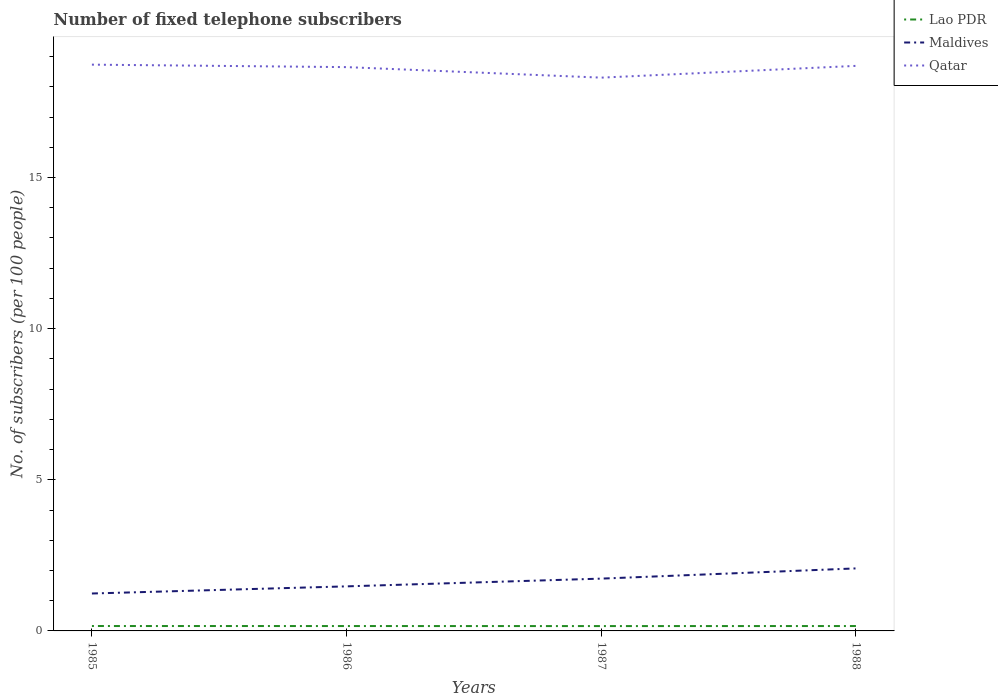How many different coloured lines are there?
Offer a terse response. 3. Does the line corresponding to Maldives intersect with the line corresponding to Lao PDR?
Make the answer very short. No. Is the number of lines equal to the number of legend labels?
Provide a succinct answer. Yes. Across all years, what is the maximum number of fixed telephone subscribers in Lao PDR?
Your response must be concise. 0.16. What is the total number of fixed telephone subscribers in Lao PDR in the graph?
Offer a very short reply. 0. What is the difference between the highest and the second highest number of fixed telephone subscribers in Qatar?
Offer a very short reply. 0.43. What is the difference between the highest and the lowest number of fixed telephone subscribers in Lao PDR?
Make the answer very short. 3. Are the values on the major ticks of Y-axis written in scientific E-notation?
Ensure brevity in your answer.  No. Does the graph contain grids?
Your response must be concise. No. Where does the legend appear in the graph?
Your response must be concise. Top right. What is the title of the graph?
Your response must be concise. Number of fixed telephone subscribers. What is the label or title of the Y-axis?
Your answer should be compact. No. of subscribers (per 100 people). What is the No. of subscribers (per 100 people) of Lao PDR in 1985?
Keep it short and to the point. 0.16. What is the No. of subscribers (per 100 people) of Maldives in 1985?
Your response must be concise. 1.24. What is the No. of subscribers (per 100 people) of Qatar in 1985?
Offer a terse response. 18.73. What is the No. of subscribers (per 100 people) in Lao PDR in 1986?
Provide a short and direct response. 0.16. What is the No. of subscribers (per 100 people) in Maldives in 1986?
Your answer should be compact. 1.47. What is the No. of subscribers (per 100 people) in Qatar in 1986?
Offer a terse response. 18.65. What is the No. of subscribers (per 100 people) of Lao PDR in 1987?
Provide a short and direct response. 0.16. What is the No. of subscribers (per 100 people) of Maldives in 1987?
Provide a short and direct response. 1.73. What is the No. of subscribers (per 100 people) of Qatar in 1987?
Your response must be concise. 18.3. What is the No. of subscribers (per 100 people) of Lao PDR in 1988?
Your answer should be very brief. 0.16. What is the No. of subscribers (per 100 people) of Maldives in 1988?
Provide a short and direct response. 2.07. What is the No. of subscribers (per 100 people) of Qatar in 1988?
Give a very brief answer. 18.69. Across all years, what is the maximum No. of subscribers (per 100 people) in Lao PDR?
Offer a very short reply. 0.16. Across all years, what is the maximum No. of subscribers (per 100 people) of Maldives?
Provide a succinct answer. 2.07. Across all years, what is the maximum No. of subscribers (per 100 people) of Qatar?
Offer a very short reply. 18.73. Across all years, what is the minimum No. of subscribers (per 100 people) in Lao PDR?
Offer a very short reply. 0.16. Across all years, what is the minimum No. of subscribers (per 100 people) of Maldives?
Give a very brief answer. 1.24. Across all years, what is the minimum No. of subscribers (per 100 people) of Qatar?
Provide a succinct answer. 18.3. What is the total No. of subscribers (per 100 people) in Lao PDR in the graph?
Offer a very short reply. 0.65. What is the total No. of subscribers (per 100 people) of Maldives in the graph?
Your answer should be very brief. 6.51. What is the total No. of subscribers (per 100 people) in Qatar in the graph?
Your answer should be compact. 74.38. What is the difference between the No. of subscribers (per 100 people) in Lao PDR in 1985 and that in 1986?
Provide a succinct answer. 0. What is the difference between the No. of subscribers (per 100 people) in Maldives in 1985 and that in 1986?
Your response must be concise. -0.24. What is the difference between the No. of subscribers (per 100 people) of Qatar in 1985 and that in 1986?
Offer a very short reply. 0.08. What is the difference between the No. of subscribers (per 100 people) in Lao PDR in 1985 and that in 1987?
Give a very brief answer. 0. What is the difference between the No. of subscribers (per 100 people) of Maldives in 1985 and that in 1987?
Provide a short and direct response. -0.49. What is the difference between the No. of subscribers (per 100 people) of Qatar in 1985 and that in 1987?
Ensure brevity in your answer.  0.43. What is the difference between the No. of subscribers (per 100 people) of Lao PDR in 1985 and that in 1988?
Your answer should be compact. 0. What is the difference between the No. of subscribers (per 100 people) of Maldives in 1985 and that in 1988?
Your response must be concise. -0.83. What is the difference between the No. of subscribers (per 100 people) of Qatar in 1985 and that in 1988?
Give a very brief answer. 0.04. What is the difference between the No. of subscribers (per 100 people) in Lao PDR in 1986 and that in 1987?
Your response must be concise. 0. What is the difference between the No. of subscribers (per 100 people) in Maldives in 1986 and that in 1987?
Give a very brief answer. -0.26. What is the difference between the No. of subscribers (per 100 people) of Qatar in 1986 and that in 1987?
Make the answer very short. 0.35. What is the difference between the No. of subscribers (per 100 people) of Lao PDR in 1986 and that in 1988?
Give a very brief answer. -0. What is the difference between the No. of subscribers (per 100 people) of Maldives in 1986 and that in 1988?
Provide a short and direct response. -0.59. What is the difference between the No. of subscribers (per 100 people) in Qatar in 1986 and that in 1988?
Your answer should be very brief. -0.04. What is the difference between the No. of subscribers (per 100 people) in Lao PDR in 1987 and that in 1988?
Provide a succinct answer. -0. What is the difference between the No. of subscribers (per 100 people) of Maldives in 1987 and that in 1988?
Your response must be concise. -0.34. What is the difference between the No. of subscribers (per 100 people) of Qatar in 1987 and that in 1988?
Your response must be concise. -0.39. What is the difference between the No. of subscribers (per 100 people) of Lao PDR in 1985 and the No. of subscribers (per 100 people) of Maldives in 1986?
Keep it short and to the point. -1.31. What is the difference between the No. of subscribers (per 100 people) of Lao PDR in 1985 and the No. of subscribers (per 100 people) of Qatar in 1986?
Provide a succinct answer. -18.49. What is the difference between the No. of subscribers (per 100 people) in Maldives in 1985 and the No. of subscribers (per 100 people) in Qatar in 1986?
Provide a short and direct response. -17.41. What is the difference between the No. of subscribers (per 100 people) of Lao PDR in 1985 and the No. of subscribers (per 100 people) of Maldives in 1987?
Provide a short and direct response. -1.57. What is the difference between the No. of subscribers (per 100 people) in Lao PDR in 1985 and the No. of subscribers (per 100 people) in Qatar in 1987?
Give a very brief answer. -18.14. What is the difference between the No. of subscribers (per 100 people) of Maldives in 1985 and the No. of subscribers (per 100 people) of Qatar in 1987?
Offer a very short reply. -17.06. What is the difference between the No. of subscribers (per 100 people) of Lao PDR in 1985 and the No. of subscribers (per 100 people) of Maldives in 1988?
Offer a very short reply. -1.91. What is the difference between the No. of subscribers (per 100 people) in Lao PDR in 1985 and the No. of subscribers (per 100 people) in Qatar in 1988?
Your response must be concise. -18.53. What is the difference between the No. of subscribers (per 100 people) of Maldives in 1985 and the No. of subscribers (per 100 people) of Qatar in 1988?
Provide a short and direct response. -17.45. What is the difference between the No. of subscribers (per 100 people) of Lao PDR in 1986 and the No. of subscribers (per 100 people) of Maldives in 1987?
Keep it short and to the point. -1.57. What is the difference between the No. of subscribers (per 100 people) in Lao PDR in 1986 and the No. of subscribers (per 100 people) in Qatar in 1987?
Offer a terse response. -18.14. What is the difference between the No. of subscribers (per 100 people) of Maldives in 1986 and the No. of subscribers (per 100 people) of Qatar in 1987?
Your response must be concise. -16.83. What is the difference between the No. of subscribers (per 100 people) of Lao PDR in 1986 and the No. of subscribers (per 100 people) of Maldives in 1988?
Your answer should be compact. -1.91. What is the difference between the No. of subscribers (per 100 people) of Lao PDR in 1986 and the No. of subscribers (per 100 people) of Qatar in 1988?
Provide a succinct answer. -18.53. What is the difference between the No. of subscribers (per 100 people) in Maldives in 1986 and the No. of subscribers (per 100 people) in Qatar in 1988?
Your response must be concise. -17.22. What is the difference between the No. of subscribers (per 100 people) of Lao PDR in 1987 and the No. of subscribers (per 100 people) of Maldives in 1988?
Provide a short and direct response. -1.91. What is the difference between the No. of subscribers (per 100 people) in Lao PDR in 1987 and the No. of subscribers (per 100 people) in Qatar in 1988?
Give a very brief answer. -18.53. What is the difference between the No. of subscribers (per 100 people) in Maldives in 1987 and the No. of subscribers (per 100 people) in Qatar in 1988?
Provide a succinct answer. -16.96. What is the average No. of subscribers (per 100 people) of Lao PDR per year?
Your response must be concise. 0.16. What is the average No. of subscribers (per 100 people) in Maldives per year?
Your answer should be very brief. 1.63. What is the average No. of subscribers (per 100 people) in Qatar per year?
Provide a succinct answer. 18.59. In the year 1985, what is the difference between the No. of subscribers (per 100 people) of Lao PDR and No. of subscribers (per 100 people) of Maldives?
Make the answer very short. -1.08. In the year 1985, what is the difference between the No. of subscribers (per 100 people) of Lao PDR and No. of subscribers (per 100 people) of Qatar?
Your response must be concise. -18.57. In the year 1985, what is the difference between the No. of subscribers (per 100 people) of Maldives and No. of subscribers (per 100 people) of Qatar?
Your answer should be very brief. -17.49. In the year 1986, what is the difference between the No. of subscribers (per 100 people) in Lao PDR and No. of subscribers (per 100 people) in Maldives?
Provide a short and direct response. -1.31. In the year 1986, what is the difference between the No. of subscribers (per 100 people) of Lao PDR and No. of subscribers (per 100 people) of Qatar?
Provide a short and direct response. -18.49. In the year 1986, what is the difference between the No. of subscribers (per 100 people) in Maldives and No. of subscribers (per 100 people) in Qatar?
Make the answer very short. -17.18. In the year 1987, what is the difference between the No. of subscribers (per 100 people) in Lao PDR and No. of subscribers (per 100 people) in Maldives?
Keep it short and to the point. -1.57. In the year 1987, what is the difference between the No. of subscribers (per 100 people) of Lao PDR and No. of subscribers (per 100 people) of Qatar?
Offer a very short reply. -18.14. In the year 1987, what is the difference between the No. of subscribers (per 100 people) in Maldives and No. of subscribers (per 100 people) in Qatar?
Provide a short and direct response. -16.57. In the year 1988, what is the difference between the No. of subscribers (per 100 people) in Lao PDR and No. of subscribers (per 100 people) in Maldives?
Your response must be concise. -1.91. In the year 1988, what is the difference between the No. of subscribers (per 100 people) of Lao PDR and No. of subscribers (per 100 people) of Qatar?
Ensure brevity in your answer.  -18.53. In the year 1988, what is the difference between the No. of subscribers (per 100 people) of Maldives and No. of subscribers (per 100 people) of Qatar?
Provide a short and direct response. -16.62. What is the ratio of the No. of subscribers (per 100 people) of Maldives in 1985 to that in 1986?
Provide a short and direct response. 0.84. What is the ratio of the No. of subscribers (per 100 people) in Qatar in 1985 to that in 1986?
Make the answer very short. 1. What is the ratio of the No. of subscribers (per 100 people) in Lao PDR in 1985 to that in 1987?
Offer a terse response. 1.01. What is the ratio of the No. of subscribers (per 100 people) of Maldives in 1985 to that in 1987?
Offer a very short reply. 0.72. What is the ratio of the No. of subscribers (per 100 people) in Qatar in 1985 to that in 1987?
Your response must be concise. 1.02. What is the ratio of the No. of subscribers (per 100 people) in Maldives in 1985 to that in 1988?
Give a very brief answer. 0.6. What is the ratio of the No. of subscribers (per 100 people) of Qatar in 1985 to that in 1988?
Offer a very short reply. 1. What is the ratio of the No. of subscribers (per 100 people) in Maldives in 1986 to that in 1987?
Ensure brevity in your answer.  0.85. What is the ratio of the No. of subscribers (per 100 people) in Qatar in 1986 to that in 1987?
Give a very brief answer. 1.02. What is the ratio of the No. of subscribers (per 100 people) of Lao PDR in 1986 to that in 1988?
Provide a short and direct response. 1. What is the ratio of the No. of subscribers (per 100 people) of Maldives in 1986 to that in 1988?
Provide a succinct answer. 0.71. What is the ratio of the No. of subscribers (per 100 people) of Lao PDR in 1987 to that in 1988?
Ensure brevity in your answer.  0.99. What is the ratio of the No. of subscribers (per 100 people) in Maldives in 1987 to that in 1988?
Provide a short and direct response. 0.84. What is the ratio of the No. of subscribers (per 100 people) in Qatar in 1987 to that in 1988?
Provide a succinct answer. 0.98. What is the difference between the highest and the second highest No. of subscribers (per 100 people) in Lao PDR?
Offer a terse response. 0. What is the difference between the highest and the second highest No. of subscribers (per 100 people) of Maldives?
Keep it short and to the point. 0.34. What is the difference between the highest and the second highest No. of subscribers (per 100 people) of Qatar?
Give a very brief answer. 0.04. What is the difference between the highest and the lowest No. of subscribers (per 100 people) in Lao PDR?
Your answer should be very brief. 0. What is the difference between the highest and the lowest No. of subscribers (per 100 people) of Maldives?
Keep it short and to the point. 0.83. What is the difference between the highest and the lowest No. of subscribers (per 100 people) of Qatar?
Offer a terse response. 0.43. 